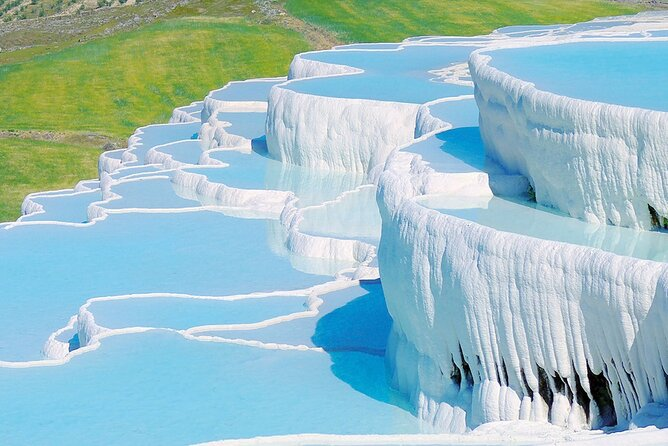Can you explain the historical significance of Pamukkale? Pamukkale, also known as 'Cotton Castle' in Turkish, holds a profound historical significance as it was once the site of the ancient Greco-Roman city of Hierapolis. This historical city was built around the hot springs and became a therapeutic center in classical antiquity, drawing patrons from all over to bathe in its healing waters. Ruins of baths, temples, and other Greek monuments can still be viewed near the terraces today, indicating the area’s long-standing appeal as a health and cultural destination. 